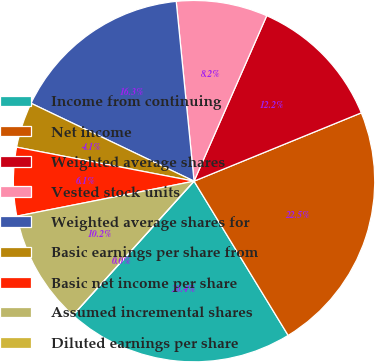Convert chart. <chart><loc_0><loc_0><loc_500><loc_500><pie_chart><fcel>Income from continuing<fcel>Net income<fcel>Weighted average shares<fcel>Vested stock units<fcel>Weighted average shares for<fcel>Basic earnings per share from<fcel>Basic net income per share<fcel>Assumed incremental shares<fcel>Diluted earnings per share<nl><fcel>20.41%<fcel>22.45%<fcel>12.24%<fcel>8.16%<fcel>16.33%<fcel>4.08%<fcel>6.12%<fcel>10.2%<fcel>0.0%<nl></chart> 